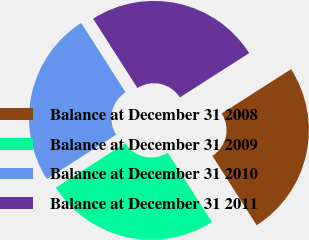Convert chart to OTSL. <chart><loc_0><loc_0><loc_500><loc_500><pie_chart><fcel>Balance at December 31 2008<fcel>Balance at December 31 2009<fcel>Balance at December 31 2010<fcel>Balance at December 31 2011<nl><fcel>25.0%<fcel>25.0%<fcel>25.0%<fcel>25.0%<nl></chart> 